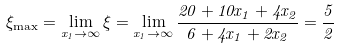<formula> <loc_0><loc_0><loc_500><loc_500>\xi _ { \max } = \lim _ { x _ { 1 } \rightarrow \infty } \xi = \lim _ { x _ { 1 } \rightarrow \infty } \frac { 2 0 + 1 0 x _ { 1 } + 4 x _ { 2 } } { 6 + 4 x _ { 1 } + 2 x _ { 2 } } = \frac { 5 } { 2 }</formula> 